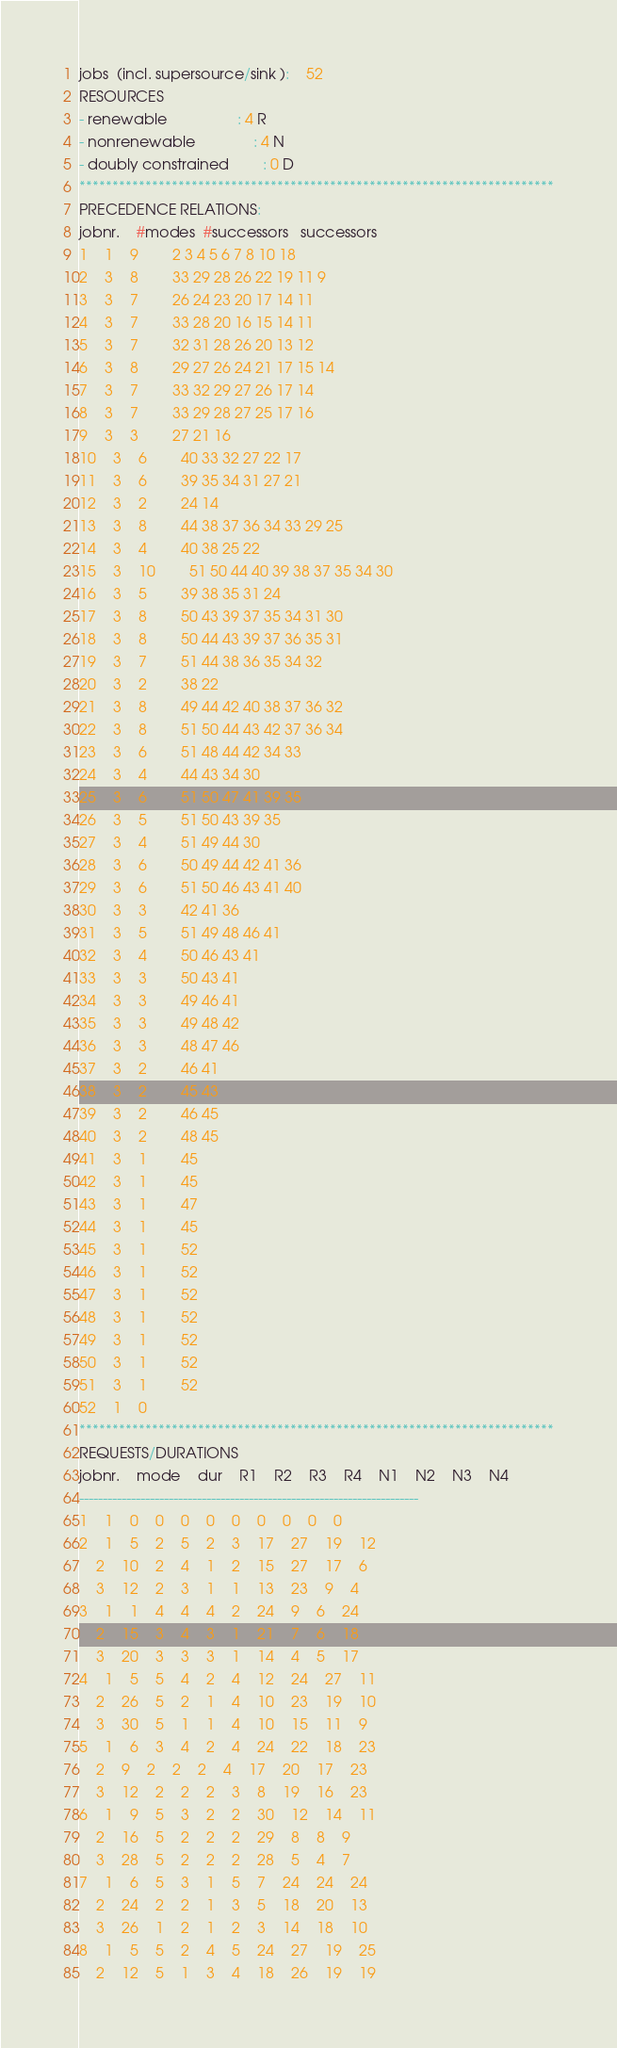Convert code to text. <code><loc_0><loc_0><loc_500><loc_500><_ObjectiveC_>jobs  (incl. supersource/sink ):	52
RESOURCES
- renewable                 : 4 R
- nonrenewable              : 4 N
- doubly constrained        : 0 D
************************************************************************
PRECEDENCE RELATIONS:
jobnr.    #modes  #successors   successors
1	1	9		2 3 4 5 6 7 8 10 18 
2	3	8		33 29 28 26 22 19 11 9 
3	3	7		26 24 23 20 17 14 11 
4	3	7		33 28 20 16 15 14 11 
5	3	7		32 31 28 26 20 13 12 
6	3	8		29 27 26 24 21 17 15 14 
7	3	7		33 32 29 27 26 17 14 
8	3	7		33 29 28 27 25 17 16 
9	3	3		27 21 16 
10	3	6		40 33 32 27 22 17 
11	3	6		39 35 34 31 27 21 
12	3	2		24 14 
13	3	8		44 38 37 36 34 33 29 25 
14	3	4		40 38 25 22 
15	3	10		51 50 44 40 39 38 37 35 34 30 
16	3	5		39 38 35 31 24 
17	3	8		50 43 39 37 35 34 31 30 
18	3	8		50 44 43 39 37 36 35 31 
19	3	7		51 44 38 36 35 34 32 
20	3	2		38 22 
21	3	8		49 44 42 40 38 37 36 32 
22	3	8		51 50 44 43 42 37 36 34 
23	3	6		51 48 44 42 34 33 
24	3	4		44 43 34 30 
25	3	6		51 50 47 41 39 35 
26	3	5		51 50 43 39 35 
27	3	4		51 49 44 30 
28	3	6		50 49 44 42 41 36 
29	3	6		51 50 46 43 41 40 
30	3	3		42 41 36 
31	3	5		51 49 48 46 41 
32	3	4		50 46 43 41 
33	3	3		50 43 41 
34	3	3		49 46 41 
35	3	3		49 48 42 
36	3	3		48 47 46 
37	3	2		46 41 
38	3	2		45 43 
39	3	2		46 45 
40	3	2		48 45 
41	3	1		45 
42	3	1		45 
43	3	1		47 
44	3	1		45 
45	3	1		52 
46	3	1		52 
47	3	1		52 
48	3	1		52 
49	3	1		52 
50	3	1		52 
51	3	1		52 
52	1	0		
************************************************************************
REQUESTS/DURATIONS
jobnr.	mode	dur	R1	R2	R3	R4	N1	N2	N3	N4	
------------------------------------------------------------------------
1	1	0	0	0	0	0	0	0	0	0	
2	1	5	2	5	2	3	17	27	19	12	
	2	10	2	4	1	2	15	27	17	6	
	3	12	2	3	1	1	13	23	9	4	
3	1	1	4	4	4	2	24	9	6	24	
	2	15	3	4	3	1	21	7	6	18	
	3	20	3	3	3	1	14	4	5	17	
4	1	5	5	4	2	4	12	24	27	11	
	2	26	5	2	1	4	10	23	19	10	
	3	30	5	1	1	4	10	15	11	9	
5	1	6	3	4	2	4	24	22	18	23	
	2	9	2	2	2	4	17	20	17	23	
	3	12	2	2	2	3	8	19	16	23	
6	1	9	5	3	2	2	30	12	14	11	
	2	16	5	2	2	2	29	8	8	9	
	3	28	5	2	2	2	28	5	4	7	
7	1	6	5	3	1	5	7	24	24	24	
	2	24	2	2	1	3	5	18	20	13	
	3	26	1	2	1	2	3	14	18	10	
8	1	5	5	2	4	5	24	27	19	25	
	2	12	5	1	3	4	18	26	19	19	</code> 